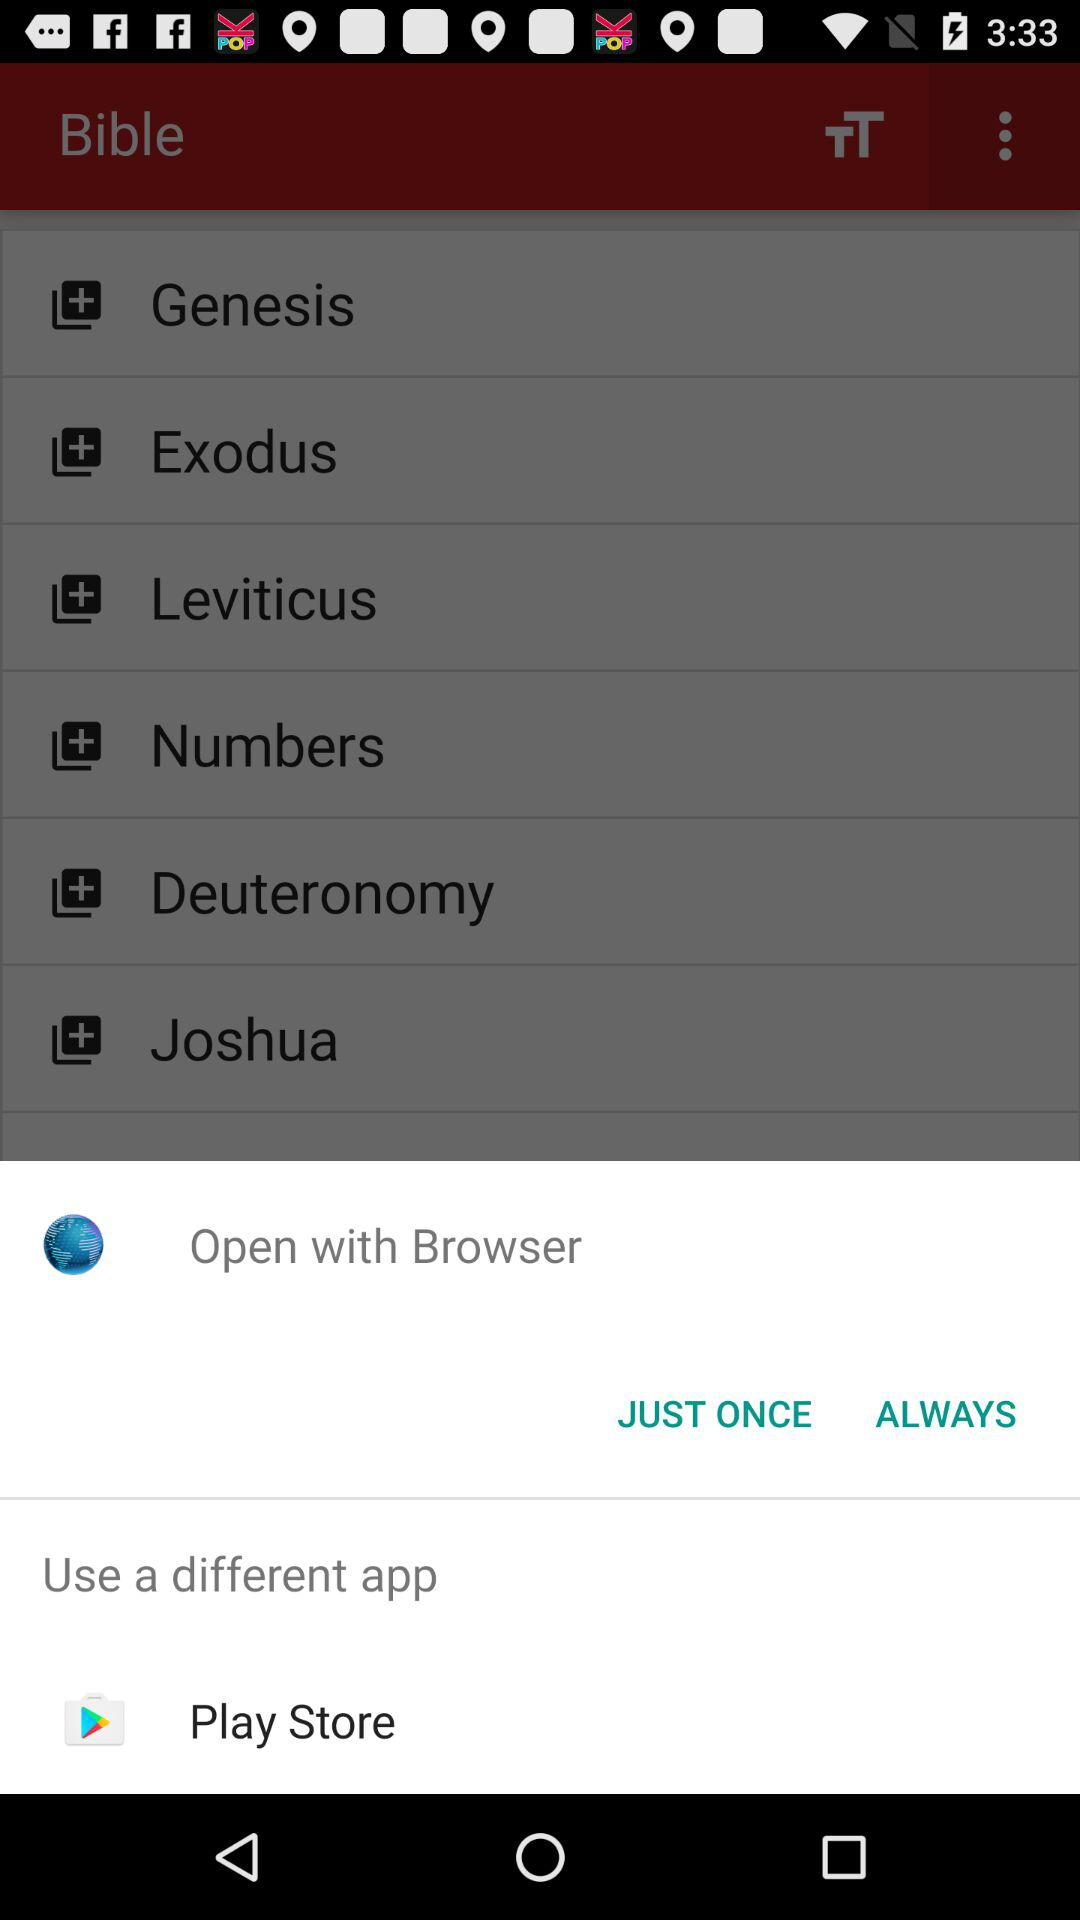What are the ways to open the Bible? The ways are "Browser" and "Play Store". 